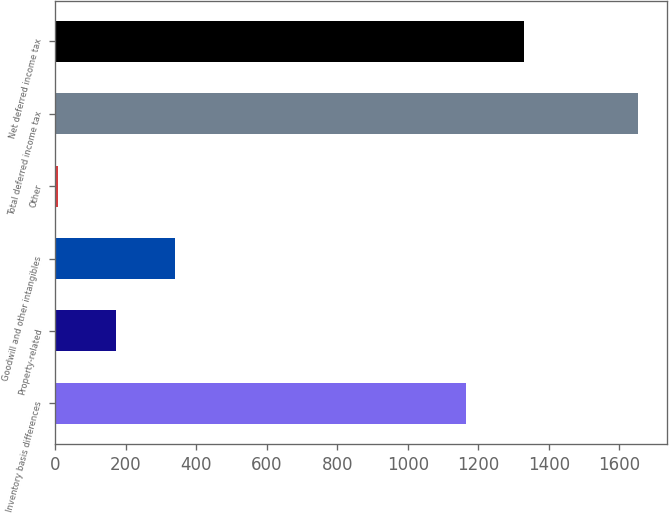Convert chart. <chart><loc_0><loc_0><loc_500><loc_500><bar_chart><fcel>Inventory basis differences<fcel>Property-related<fcel>Goodwill and other intangibles<fcel>Other<fcel>Total deferred income tax<fcel>Net deferred income tax<nl><fcel>1164<fcel>171.6<fcel>340<fcel>7<fcel>1653<fcel>1328.6<nl></chart> 